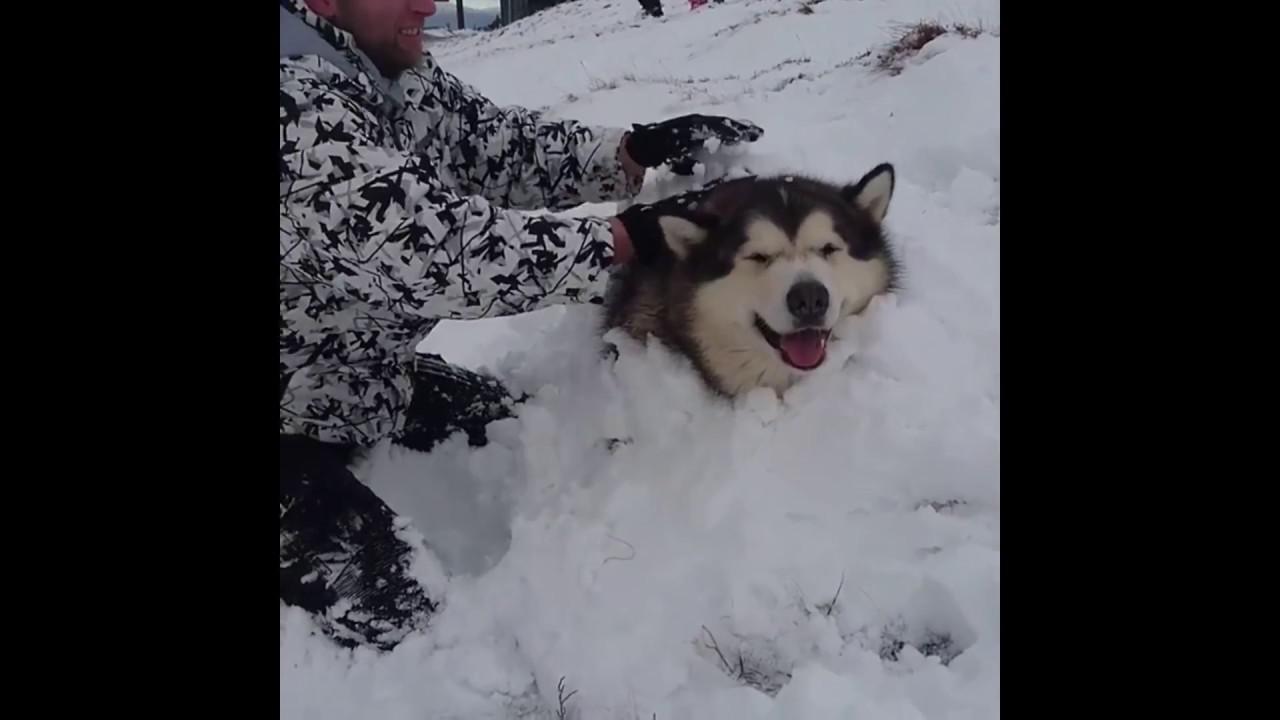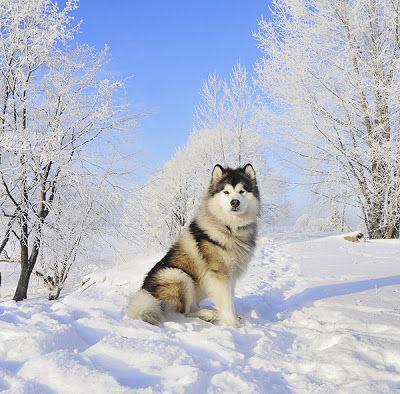The first image is the image on the left, the second image is the image on the right. Assess this claim about the two images: "The left and right image contains the same number of dogs with at least one standing in the snow.". Correct or not? Answer yes or no. No. The first image is the image on the left, the second image is the image on the right. Examine the images to the left and right. Is the description "One image shows a dog sitting upright on snow-covered ground, and the other image shows a forward-facing dog with snow mounded in front of it." accurate? Answer yes or no. Yes. 